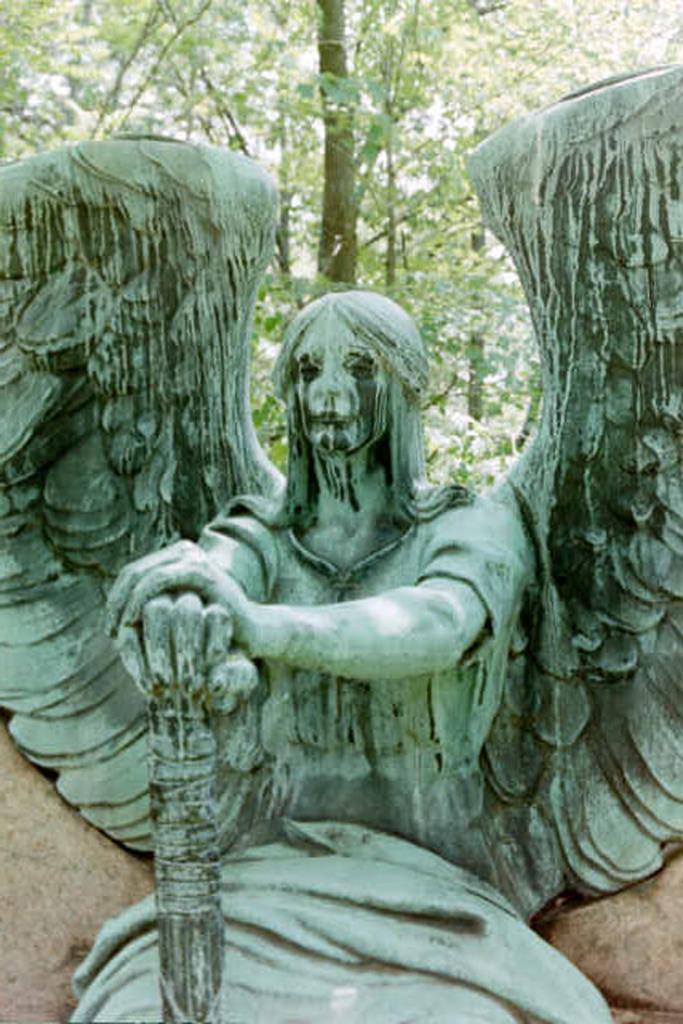Could you give a brief overview of what you see in this image? In the front of the image there is a statue. In the background of the image there are trees. 